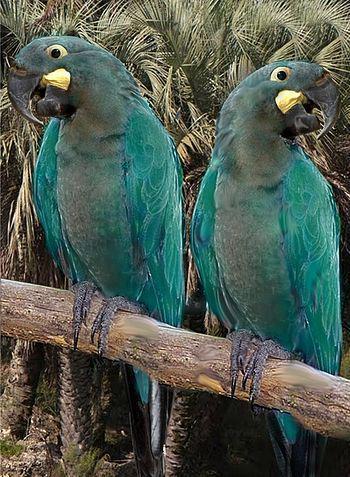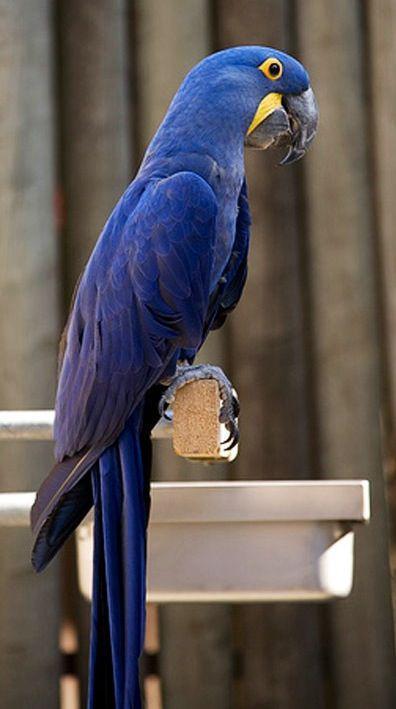The first image is the image on the left, the second image is the image on the right. Examine the images to the left and right. Is the description "There are two birds in the image on the right." accurate? Answer yes or no. No. 